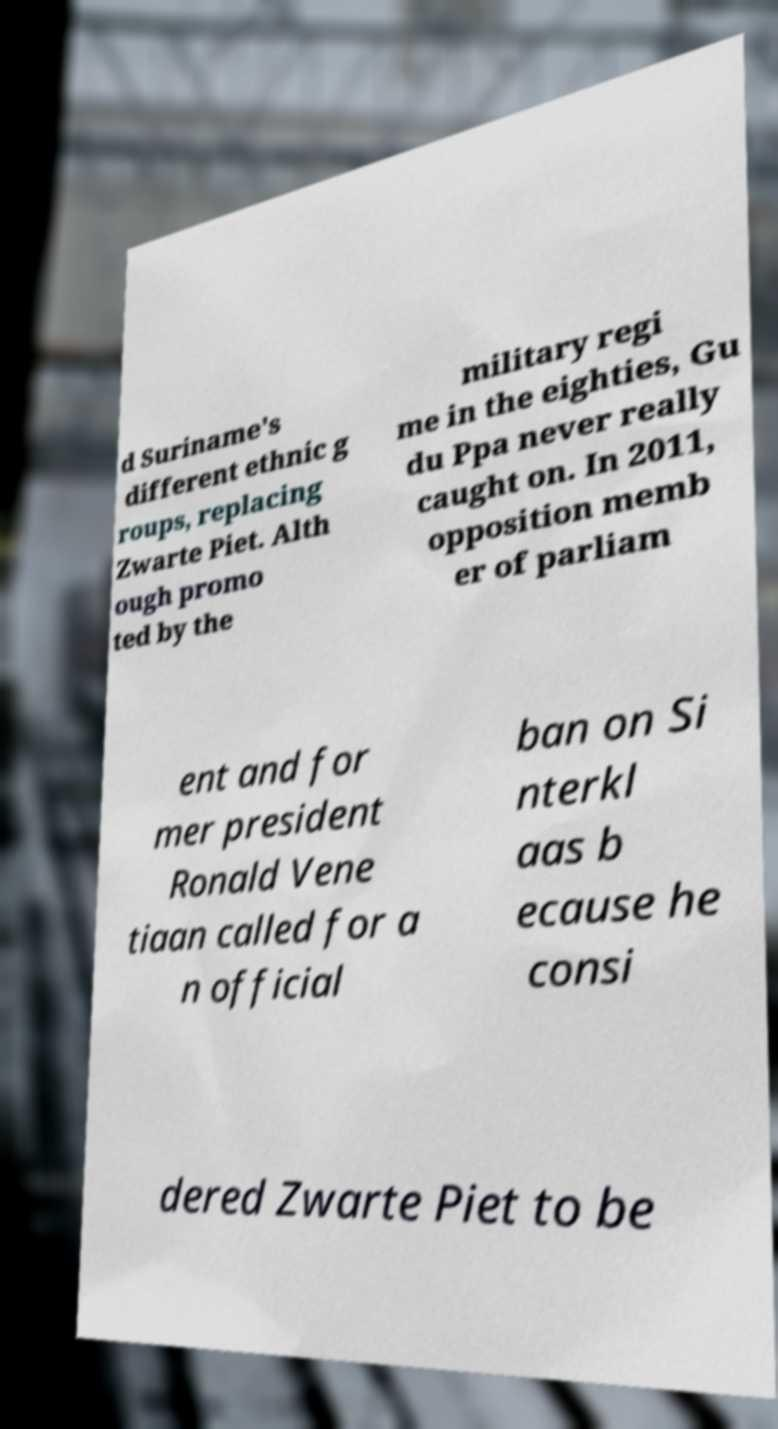Can you read and provide the text displayed in the image?This photo seems to have some interesting text. Can you extract and type it out for me? d Suriname's different ethnic g roups, replacing Zwarte Piet. Alth ough promo ted by the military regi me in the eighties, Gu du Ppa never really caught on. In 2011, opposition memb er of parliam ent and for mer president Ronald Vene tiaan called for a n official ban on Si nterkl aas b ecause he consi dered Zwarte Piet to be 